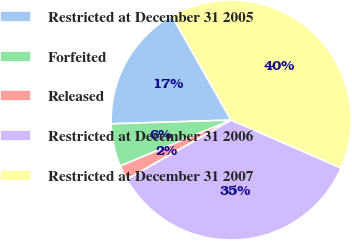<chart> <loc_0><loc_0><loc_500><loc_500><pie_chart><fcel>Restricted at December 31 2005<fcel>Forfeited<fcel>Released<fcel>Restricted at December 31 2006<fcel>Restricted at December 31 2007<nl><fcel>17.28%<fcel>5.75%<fcel>1.98%<fcel>35.23%<fcel>39.76%<nl></chart> 